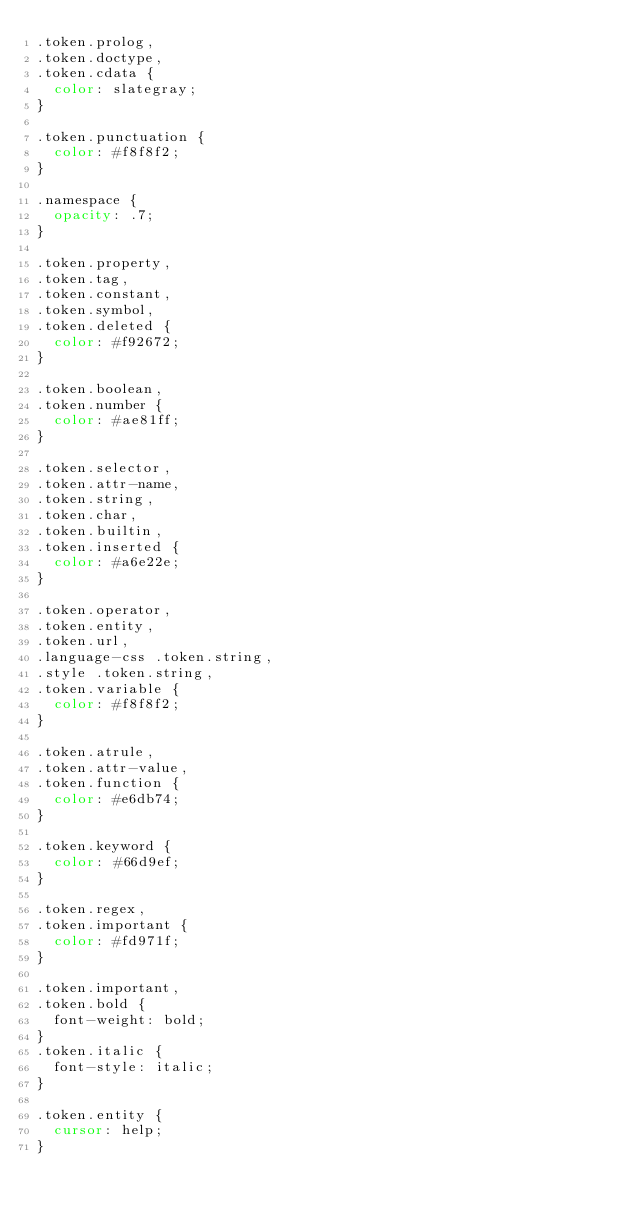<code> <loc_0><loc_0><loc_500><loc_500><_CSS_>.token.prolog,
.token.doctype,
.token.cdata {
	color: slategray;
}

.token.punctuation {
	color: #f8f8f2;
}

.namespace {
	opacity: .7;
}

.token.property,
.token.tag,
.token.constant,
.token.symbol,
.token.deleted {
	color: #f92672;
}

.token.boolean,
.token.number {
	color: #ae81ff;
}

.token.selector,
.token.attr-name,
.token.string,
.token.char,
.token.builtin,
.token.inserted {
	color: #a6e22e;
}

.token.operator,
.token.entity,
.token.url,
.language-css .token.string,
.style .token.string,
.token.variable {
	color: #f8f8f2;
}

.token.atrule,
.token.attr-value,
.token.function {
	color: #e6db74;
}

.token.keyword {
	color: #66d9ef;
}

.token.regex,
.token.important {
	color: #fd971f;
}

.token.important,
.token.bold {
	font-weight: bold;
}
.token.italic {
	font-style: italic;
}

.token.entity {
	cursor: help;
}

</code> 